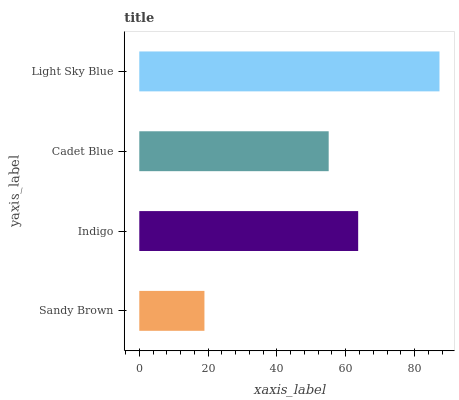Is Sandy Brown the minimum?
Answer yes or no. Yes. Is Light Sky Blue the maximum?
Answer yes or no. Yes. Is Indigo the minimum?
Answer yes or no. No. Is Indigo the maximum?
Answer yes or no. No. Is Indigo greater than Sandy Brown?
Answer yes or no. Yes. Is Sandy Brown less than Indigo?
Answer yes or no. Yes. Is Sandy Brown greater than Indigo?
Answer yes or no. No. Is Indigo less than Sandy Brown?
Answer yes or no. No. Is Indigo the high median?
Answer yes or no. Yes. Is Cadet Blue the low median?
Answer yes or no. Yes. Is Sandy Brown the high median?
Answer yes or no. No. Is Sandy Brown the low median?
Answer yes or no. No. 